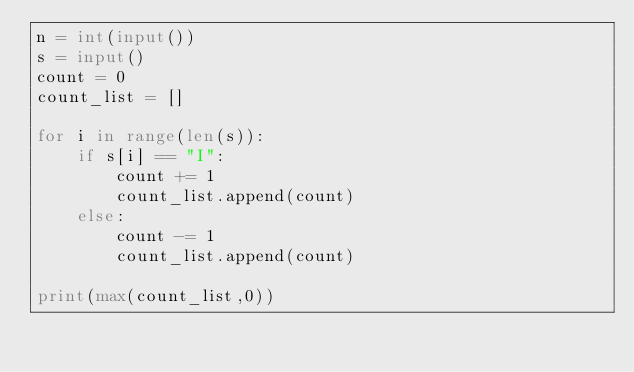<code> <loc_0><loc_0><loc_500><loc_500><_Python_>n = int(input())
s = input()
count = 0
count_list = []

for i in range(len(s)):
    if s[i] == "I":
        count += 1
        count_list.append(count)
    else:
        count -= 1
        count_list.append(count)

print(max(count_list,0))</code> 